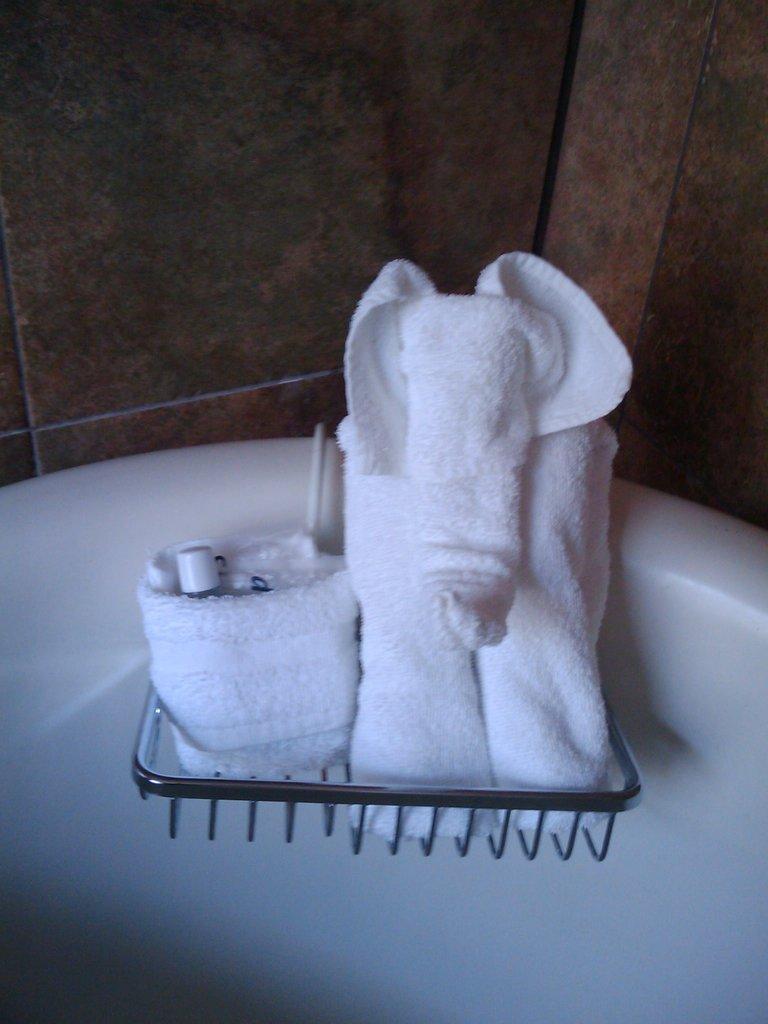Could you give a brief overview of what you see in this image? In this image we can see a stand. On the stand there are towels. Also there is a white object. In the back there is a wall. 